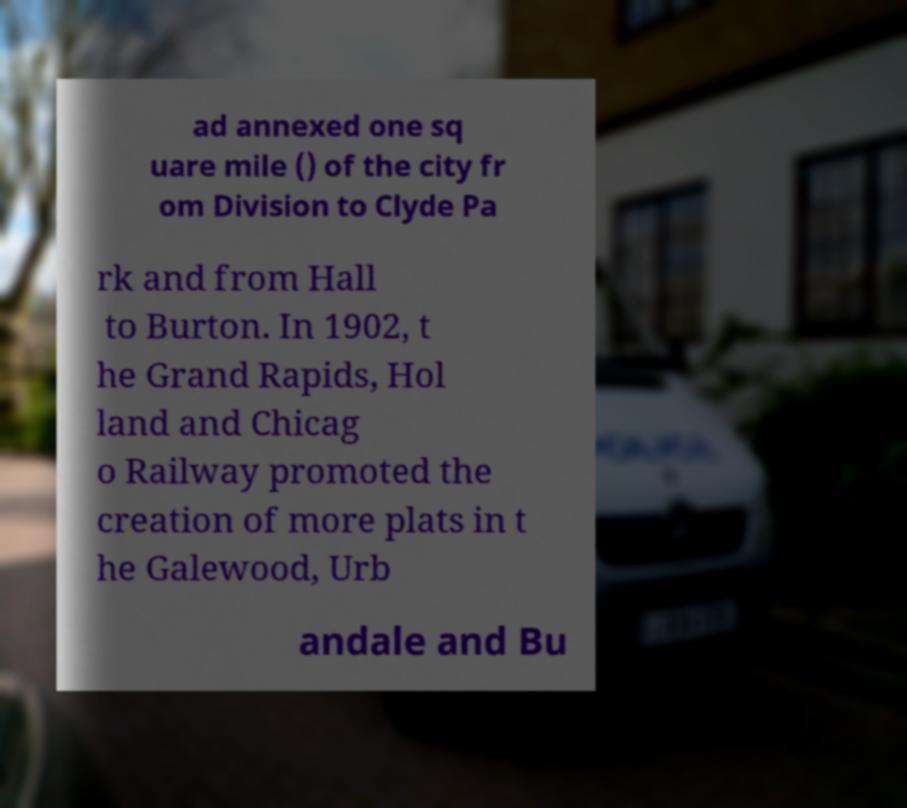There's text embedded in this image that I need extracted. Can you transcribe it verbatim? ad annexed one sq uare mile () of the city fr om Division to Clyde Pa rk and from Hall to Burton. In 1902, t he Grand Rapids, Hol land and Chicag o Railway promoted the creation of more plats in t he Galewood, Urb andale and Bu 